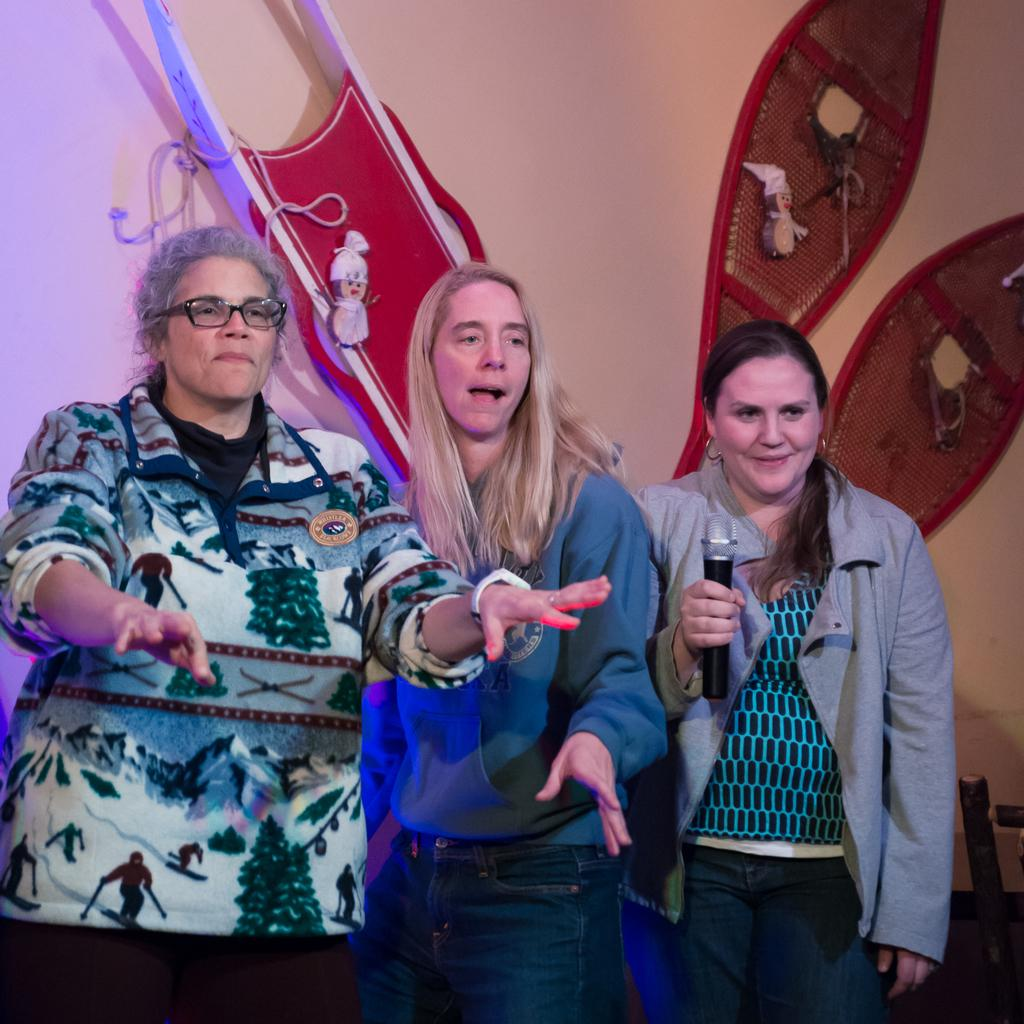How many people are in the image? There are three people standing in the center of the image. What is one person doing in the image? One person is holding a microphone. What can be seen in the background of the image? There are objects visible in the background of the image. What type of structure is in the background of the image? There is a wall in the background of the image. What type of ring is the person wearing on their finger in the image? There is no ring visible on any of the people's fingers in the image. What type of badge is the person wearing on their shirt in the image? There is no badge visible on any of the people's shirts in the image. 